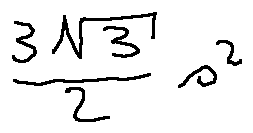Convert formula to latex. <formula><loc_0><loc_0><loc_500><loc_500>\frac { 3 \sqrt { 3 } } { 2 } s ^ { 2 }</formula> 